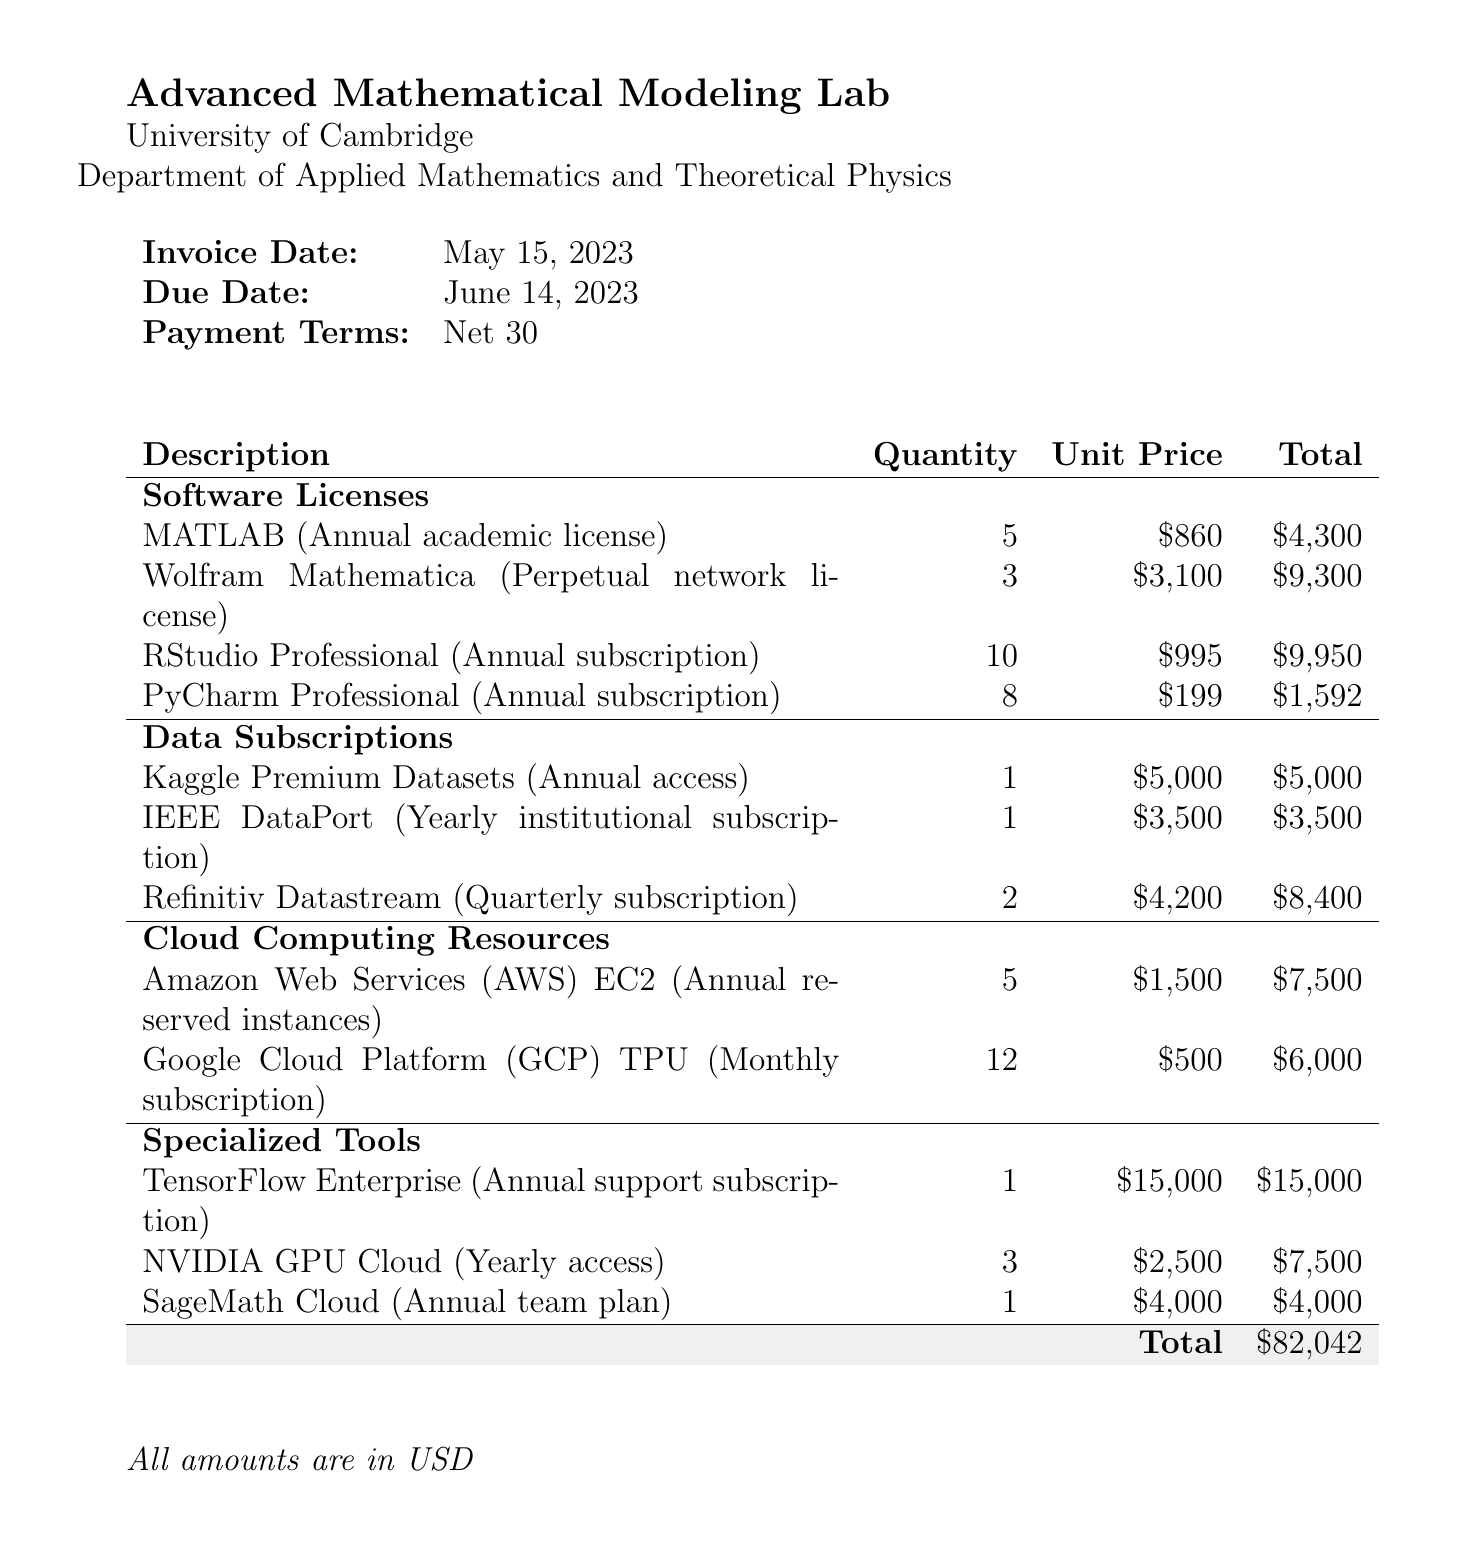What is the total cost? The total cost is explicitly stated at the bottom of the invoice, summarizing all expenses incurred for the items listed.
Answer: $82,042 How many licenses for MATLAB were purchased? The quantity of MATLAB licenses is specified in the software licenses section, which states that 5 licenses were acquired.
Answer: 5 What is the unit price of the Wolfram Mathematica license? The unit price for the Wolfram Mathematica license is provided in the software licenses section as $3,100.
Answer: $3,100 What is the due date for the invoice? The due date is clearly listed in the invoice details, providing a specific time frame for payment completion.
Answer: June 14, 2023 Which institution is issuing the invoice? The name of the institution is presented at the top of the invoice under the research group details.
Answer: University of Cambridge How many Google Cloud Platform TPU subscriptions were billed? The quantity for the Google Cloud Platform TPU subscriptions is detailed in the cloud computing resources section of the invoice.
Answer: 12 What type of license is for RStudio Professional? The type of license for RStudio Professional is described in its entry as an annual subscription for collaborative statistical computing.
Answer: Annual subscription How many items fall under the category of Data Subscriptions? The total number of items categorized as Data Subscriptions is found by counting the individual entries listed in that section.
Answer: 3 What are the payment terms specified in the invoice? The payment terms are explicitly mentioned in the invoice details section, detailing when payment is expected.
Answer: Net 30 